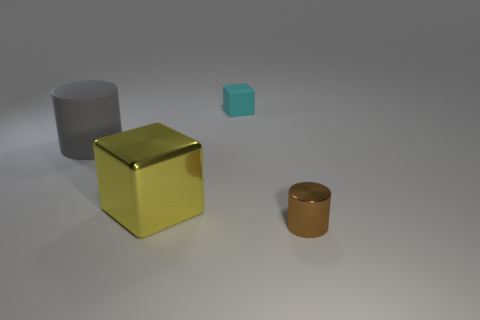Add 4 small objects. How many objects exist? 8 Add 4 green metallic cylinders. How many green metallic cylinders exist? 4 Subtract 0 green cubes. How many objects are left? 4 Subtract all large gray cylinders. Subtract all small cyan cubes. How many objects are left? 2 Add 4 cyan things. How many cyan things are left? 5 